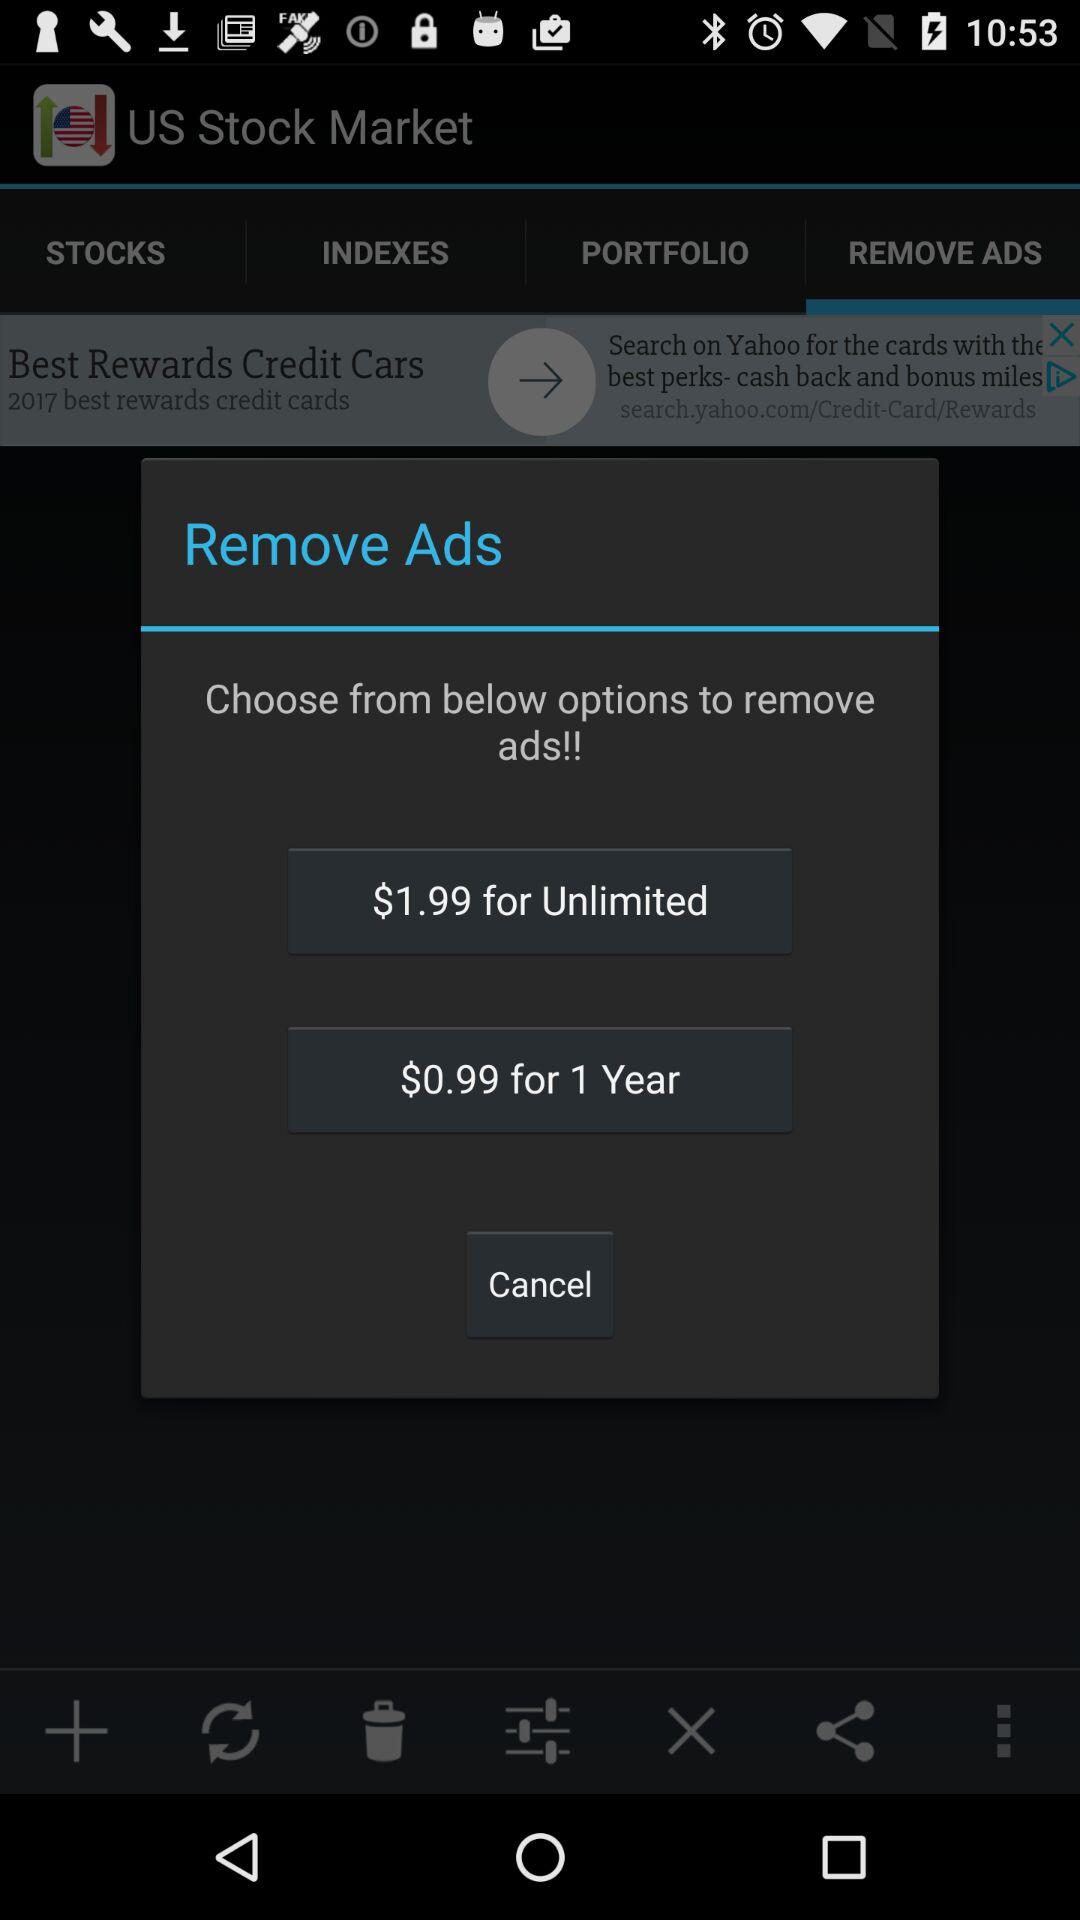For which plan is the charge $1.99? The charge of $1.99 is for the "Unlimited" plan. 